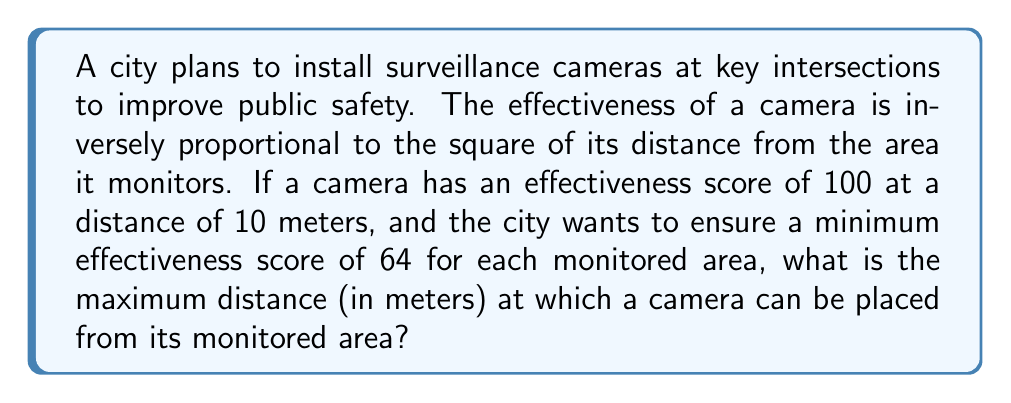What is the answer to this math problem? Let's approach this step-by-step:

1) We're told that the effectiveness (E) is inversely proportional to the square of the distance (d). This can be expressed mathematically as:

   $E \propto \frac{1}{d^2}$

2) We can turn this into an equation by introducing a constant k:

   $E = \frac{k}{d^2}$

3) We're given that when d = 10 meters, E = 100. Let's use this to find k:

   $100 = \frac{k}{10^2}$
   $100 = \frac{k}{100}$
   $k = 100 * 100 = 10,000$

4) So our equation for effectiveness is:

   $E = \frac{10,000}{d^2}$

5) Now, we want to find d when E = 64 (the minimum effectiveness score). Let's substitute this into our equation:

   $64 = \frac{10,000}{d^2}$

6) Solving for d:

   $d^2 = \frac{10,000}{64}$
   $d^2 = 156.25$
   $d = \sqrt{156.25} = 12.5$

Therefore, the maximum distance at which a camera can be placed to ensure a minimum effectiveness score of 64 is 12.5 meters.
Answer: 12.5 meters 